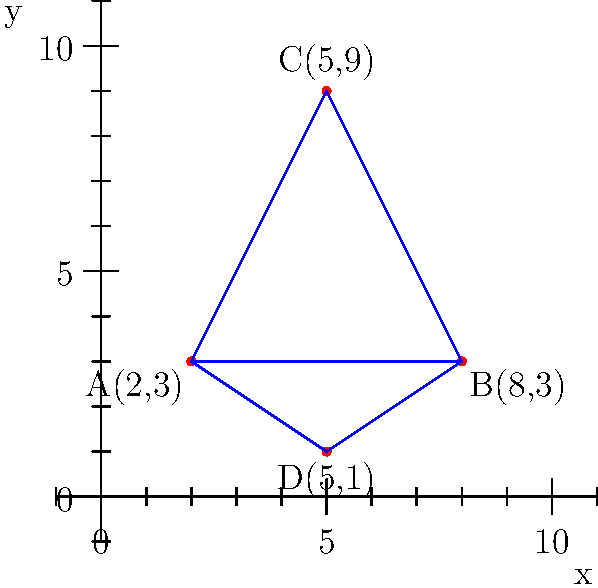As a hotel resort owner planning an eco-friendly golf course, you need to determine the optimal area for the course within the given property boundaries. The coordinates of the boundary points are A(2,3), B(8,3), C(5,9), and D(5,1) on a coordinate plane where each unit represents 100 meters. What is the total area (in square meters) of the two triangular regions formed by these points? To solve this problem, we need to calculate the areas of two triangles: ABC and ABD.

Step 1: Calculate the area of triangle ABC using the formula:
$$\text{Area}_{\triangle ABC} = \frac{1}{2}|x_A(y_B - y_C) + x_B(y_C - y_A) + x_C(y_A - y_B)|$$

Substituting the values:
$$\text{Area}_{\triangle ABC} = \frac{1}{2}|2(3 - 9) + 8(9 - 3) + 5(3 - 3)|$$
$$= \frac{1}{2}|2(-6) + 8(6) + 5(0)|$$
$$= \frac{1}{2}|-12 + 48 + 0|$$
$$= \frac{1}{2}(36) = 18$$

Step 2: Calculate the area of triangle ABD using the same formula:
$$\text{Area}_{\triangle ABD} = \frac{1}{2}|x_A(y_B - y_D) + x_B(y_D - y_A) + x_D(y_A - y_B)|$$

Substituting the values:
$$\text{Area}_{\triangle ABD} = \frac{1}{2}|2(3 - 1) + 8(1 - 3) + 5(3 - 3)|$$
$$= \frac{1}{2}|2(2) + 8(-2) + 5(0)|$$
$$= \frac{1}{2}|4 - 16 + 0|$$
$$= \frac{1}{2}(12) = 6$$

Step 3: Sum the areas of both triangles:
Total Area = $\text{Area}_{\triangle ABC} + \text{Area}_{\triangle ABD} = 18 + 6 = 24$

Step 4: Convert the area to square meters:
Since each unit represents 100 meters, we need to multiply the result by $100^2 = 10,000$:

Total Area in square meters = $24 \times 10,000 = 240,000$ sq meters
Answer: 240,000 sq meters 